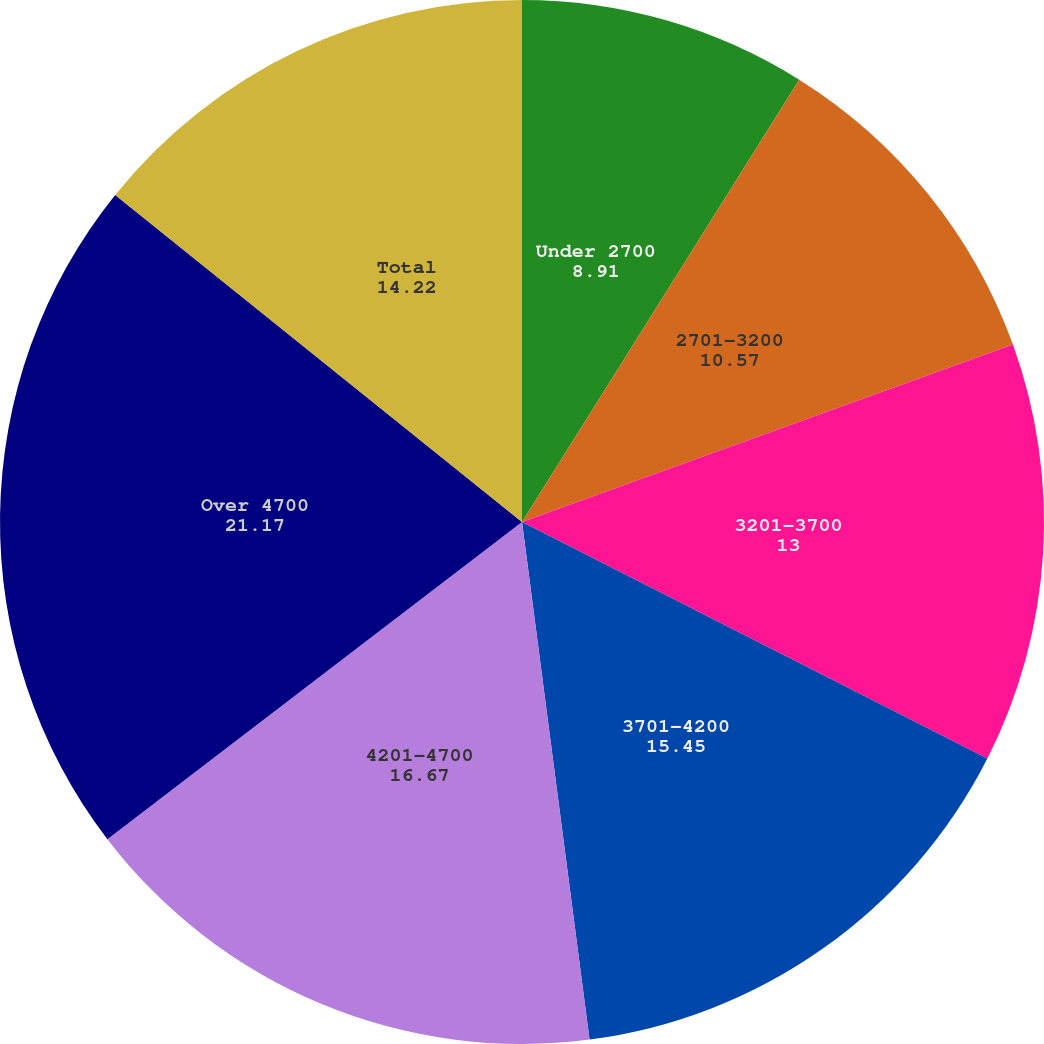Convert chart to OTSL. <chart><loc_0><loc_0><loc_500><loc_500><pie_chart><fcel>Under 2700<fcel>2701-3200<fcel>3201-3700<fcel>3701-4200<fcel>4201-4700<fcel>Over 4700<fcel>Total<nl><fcel>8.91%<fcel>10.57%<fcel>13.0%<fcel>15.45%<fcel>16.67%<fcel>21.17%<fcel>14.22%<nl></chart> 